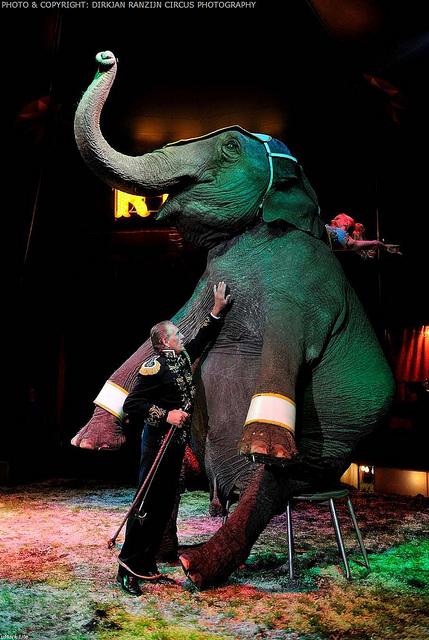What is the animal sitting on?
Keep it brief. Stool. What is the man holding in his hand?
Concise answer only. Stick. What is the animal?
Write a very short answer. Elephant. 